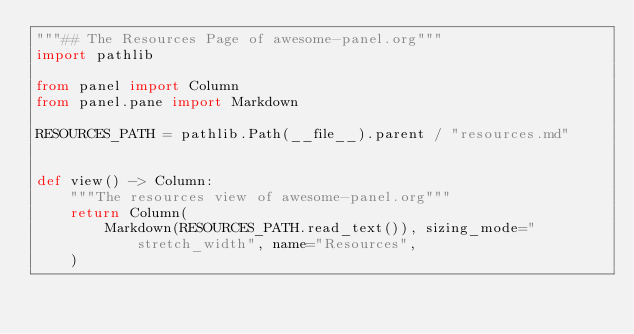<code> <loc_0><loc_0><loc_500><loc_500><_Python_>"""## The Resources Page of awesome-panel.org"""
import pathlib

from panel import Column
from panel.pane import Markdown

RESOURCES_PATH = pathlib.Path(__file__).parent / "resources.md"


def view() -> Column:
    """The resources view of awesome-panel.org"""
    return Column(
        Markdown(RESOURCES_PATH.read_text()), sizing_mode="stretch_width", name="Resources",
    )
</code> 